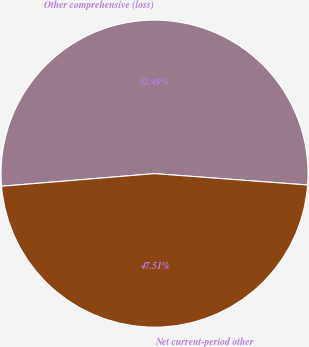Convert chart. <chart><loc_0><loc_0><loc_500><loc_500><pie_chart><fcel>Other comprehensive (loss)<fcel>Net current-period other<nl><fcel>52.49%<fcel>47.51%<nl></chart> 